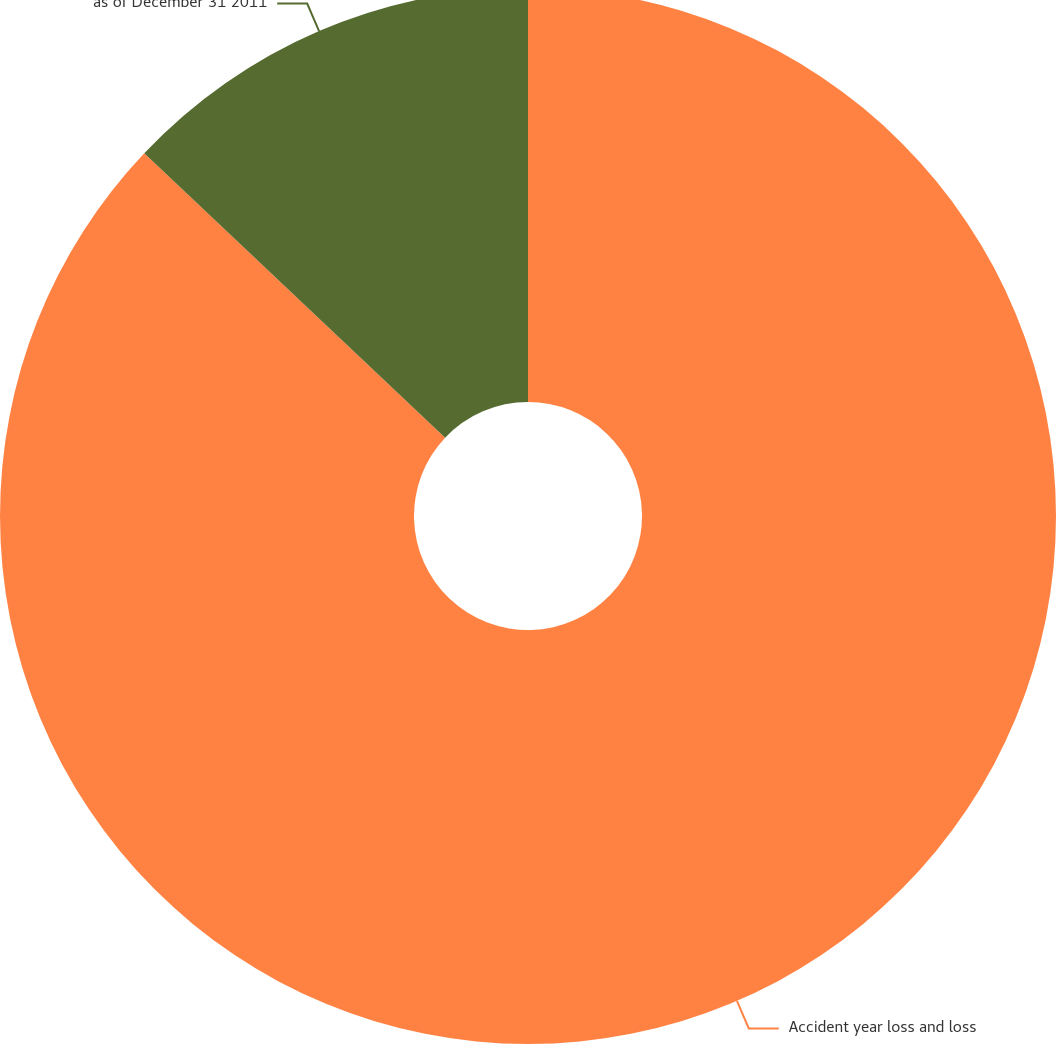Convert chart to OTSL. <chart><loc_0><loc_0><loc_500><loc_500><pie_chart><fcel>Accident year loss and loss<fcel>as of December 31 2011<nl><fcel>87.05%<fcel>12.95%<nl></chart> 